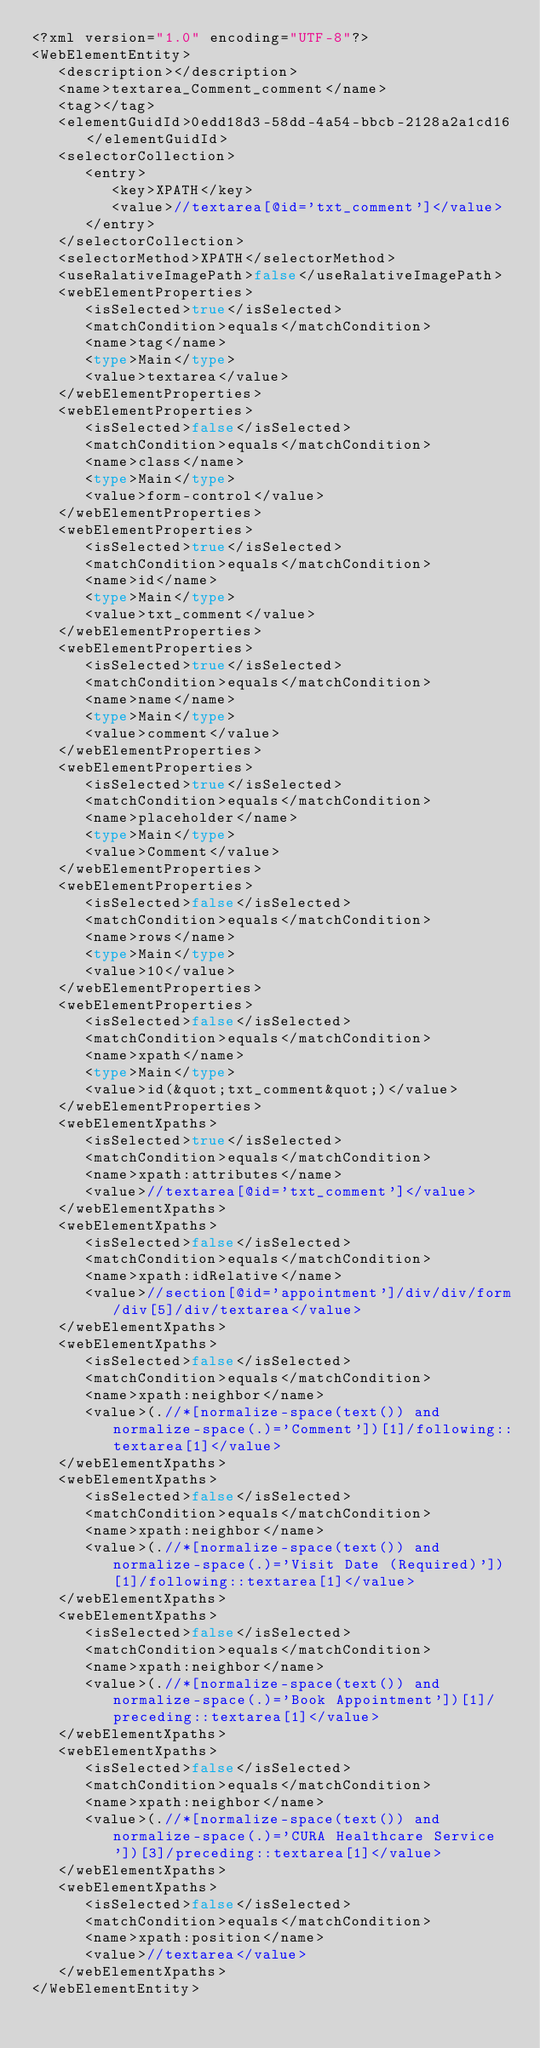<code> <loc_0><loc_0><loc_500><loc_500><_Rust_><?xml version="1.0" encoding="UTF-8"?>
<WebElementEntity>
   <description></description>
   <name>textarea_Comment_comment</name>
   <tag></tag>
   <elementGuidId>0edd18d3-58dd-4a54-bbcb-2128a2a1cd16</elementGuidId>
   <selectorCollection>
      <entry>
         <key>XPATH</key>
         <value>//textarea[@id='txt_comment']</value>
      </entry>
   </selectorCollection>
   <selectorMethod>XPATH</selectorMethod>
   <useRalativeImagePath>false</useRalativeImagePath>
   <webElementProperties>
      <isSelected>true</isSelected>
      <matchCondition>equals</matchCondition>
      <name>tag</name>
      <type>Main</type>
      <value>textarea</value>
   </webElementProperties>
   <webElementProperties>
      <isSelected>false</isSelected>
      <matchCondition>equals</matchCondition>
      <name>class</name>
      <type>Main</type>
      <value>form-control</value>
   </webElementProperties>
   <webElementProperties>
      <isSelected>true</isSelected>
      <matchCondition>equals</matchCondition>
      <name>id</name>
      <type>Main</type>
      <value>txt_comment</value>
   </webElementProperties>
   <webElementProperties>
      <isSelected>true</isSelected>
      <matchCondition>equals</matchCondition>
      <name>name</name>
      <type>Main</type>
      <value>comment</value>
   </webElementProperties>
   <webElementProperties>
      <isSelected>true</isSelected>
      <matchCondition>equals</matchCondition>
      <name>placeholder</name>
      <type>Main</type>
      <value>Comment</value>
   </webElementProperties>
   <webElementProperties>
      <isSelected>false</isSelected>
      <matchCondition>equals</matchCondition>
      <name>rows</name>
      <type>Main</type>
      <value>10</value>
   </webElementProperties>
   <webElementProperties>
      <isSelected>false</isSelected>
      <matchCondition>equals</matchCondition>
      <name>xpath</name>
      <type>Main</type>
      <value>id(&quot;txt_comment&quot;)</value>
   </webElementProperties>
   <webElementXpaths>
      <isSelected>true</isSelected>
      <matchCondition>equals</matchCondition>
      <name>xpath:attributes</name>
      <value>//textarea[@id='txt_comment']</value>
   </webElementXpaths>
   <webElementXpaths>
      <isSelected>false</isSelected>
      <matchCondition>equals</matchCondition>
      <name>xpath:idRelative</name>
      <value>//section[@id='appointment']/div/div/form/div[5]/div/textarea</value>
   </webElementXpaths>
   <webElementXpaths>
      <isSelected>false</isSelected>
      <matchCondition>equals</matchCondition>
      <name>xpath:neighbor</name>
      <value>(.//*[normalize-space(text()) and normalize-space(.)='Comment'])[1]/following::textarea[1]</value>
   </webElementXpaths>
   <webElementXpaths>
      <isSelected>false</isSelected>
      <matchCondition>equals</matchCondition>
      <name>xpath:neighbor</name>
      <value>(.//*[normalize-space(text()) and normalize-space(.)='Visit Date (Required)'])[1]/following::textarea[1]</value>
   </webElementXpaths>
   <webElementXpaths>
      <isSelected>false</isSelected>
      <matchCondition>equals</matchCondition>
      <name>xpath:neighbor</name>
      <value>(.//*[normalize-space(text()) and normalize-space(.)='Book Appointment'])[1]/preceding::textarea[1]</value>
   </webElementXpaths>
   <webElementXpaths>
      <isSelected>false</isSelected>
      <matchCondition>equals</matchCondition>
      <name>xpath:neighbor</name>
      <value>(.//*[normalize-space(text()) and normalize-space(.)='CURA Healthcare Service'])[3]/preceding::textarea[1]</value>
   </webElementXpaths>
   <webElementXpaths>
      <isSelected>false</isSelected>
      <matchCondition>equals</matchCondition>
      <name>xpath:position</name>
      <value>//textarea</value>
   </webElementXpaths>
</WebElementEntity>
</code> 